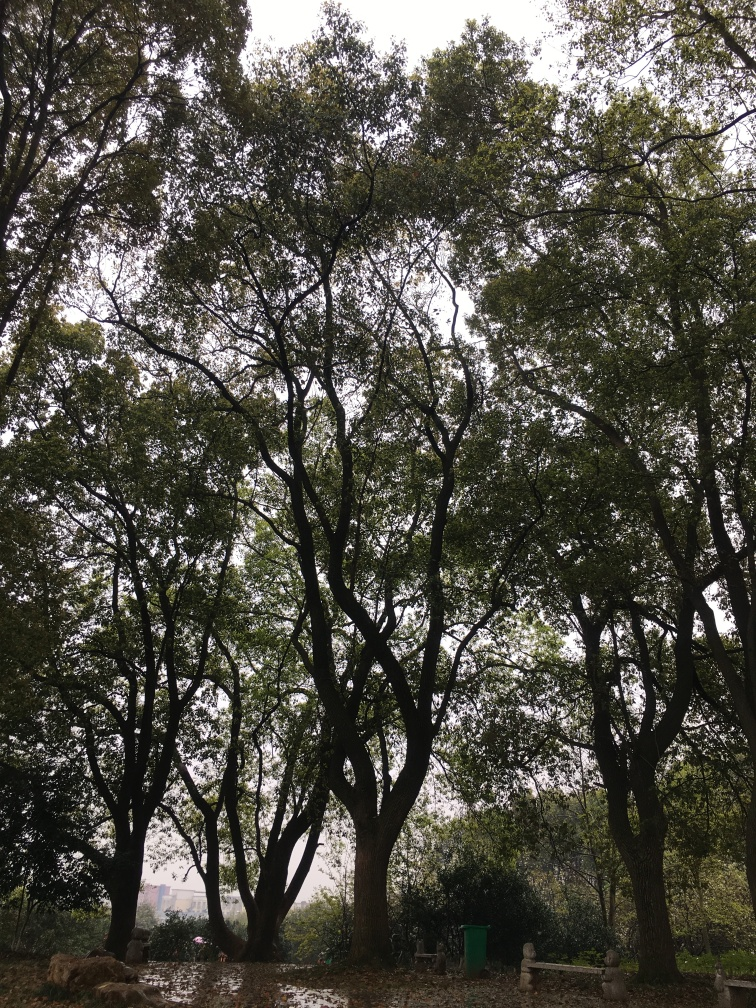What is the clarity of this image? The image appears to have a high resolution with distinct details, providing a clear view of the trees and foliage. The lighting is soft, suggesting an overcast sky, which contributes to the overall serene atmosphere without causing glare or harsh shadows. 